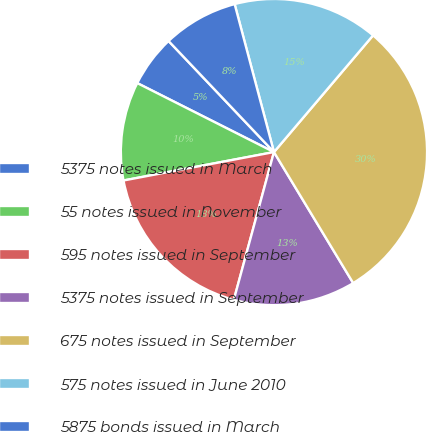Convert chart. <chart><loc_0><loc_0><loc_500><loc_500><pie_chart><fcel>5375 notes issued in March<fcel>55 notes issued in November<fcel>595 notes issued in September<fcel>5375 notes issued in September<fcel>675 notes issued in September<fcel>575 notes issued in June 2010<fcel>5875 bonds issued in March<nl><fcel>5.48%<fcel>10.41%<fcel>17.81%<fcel>12.88%<fcel>30.14%<fcel>15.34%<fcel>7.95%<nl></chart> 